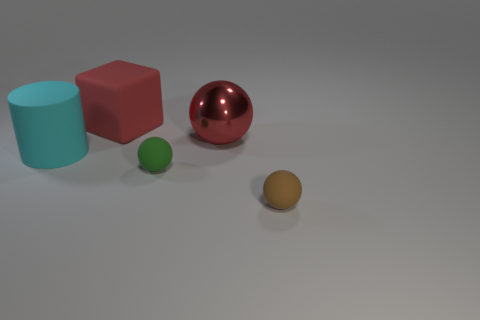Subtract all brown cylinders. Subtract all gray blocks. How many cylinders are left? 1 Add 2 red metal spheres. How many objects exist? 7 Subtract all spheres. How many objects are left? 2 Subtract all big gray cylinders. Subtract all large red metallic balls. How many objects are left? 4 Add 1 green balls. How many green balls are left? 2 Add 5 cylinders. How many cylinders exist? 6 Subtract 1 green spheres. How many objects are left? 4 